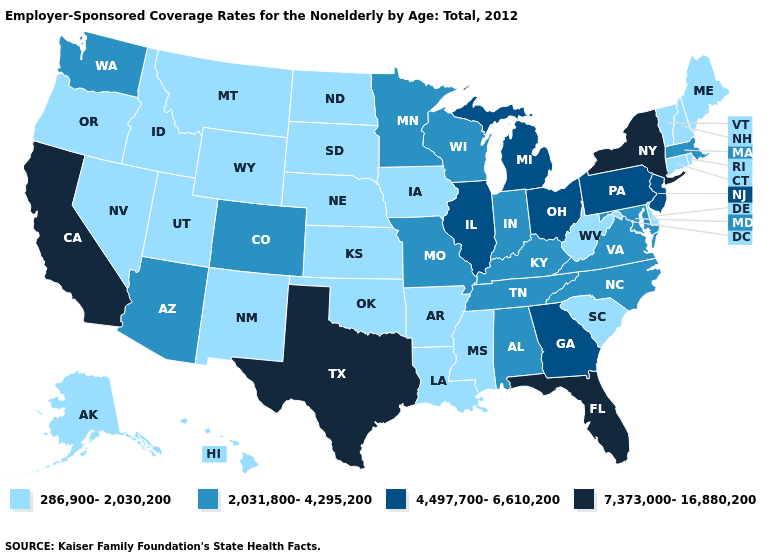Does the map have missing data?
Short answer required. No. Does Illinois have a higher value than New Jersey?
Write a very short answer. No. Name the states that have a value in the range 2,031,800-4,295,200?
Give a very brief answer. Alabama, Arizona, Colorado, Indiana, Kentucky, Maryland, Massachusetts, Minnesota, Missouri, North Carolina, Tennessee, Virginia, Washington, Wisconsin. Name the states that have a value in the range 7,373,000-16,880,200?
Be succinct. California, Florida, New York, Texas. What is the value of Colorado?
Give a very brief answer. 2,031,800-4,295,200. What is the value of Pennsylvania?
Quick response, please. 4,497,700-6,610,200. Name the states that have a value in the range 4,497,700-6,610,200?
Keep it brief. Georgia, Illinois, Michigan, New Jersey, Ohio, Pennsylvania. What is the value of Utah?
Quick response, please. 286,900-2,030,200. Which states have the lowest value in the MidWest?
Keep it brief. Iowa, Kansas, Nebraska, North Dakota, South Dakota. What is the value of Utah?
Write a very short answer. 286,900-2,030,200. What is the value of New York?
Quick response, please. 7,373,000-16,880,200. What is the value of Kentucky?
Quick response, please. 2,031,800-4,295,200. Does North Dakota have the lowest value in the USA?
Be succinct. Yes. Does North Dakota have the lowest value in the USA?
Quick response, please. Yes. Which states hav the highest value in the MidWest?
Keep it brief. Illinois, Michigan, Ohio. 